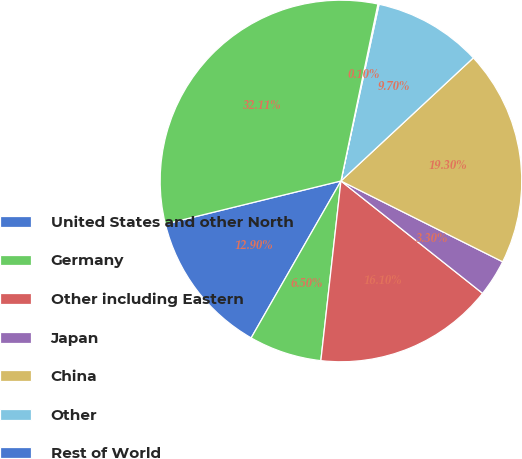<chart> <loc_0><loc_0><loc_500><loc_500><pie_chart><fcel>United States and other North<fcel>Germany<fcel>Other including Eastern<fcel>Japan<fcel>China<fcel>Other<fcel>Rest of World<fcel>Total<nl><fcel>12.9%<fcel>6.5%<fcel>16.1%<fcel>3.3%<fcel>19.3%<fcel>9.7%<fcel>0.1%<fcel>32.11%<nl></chart> 